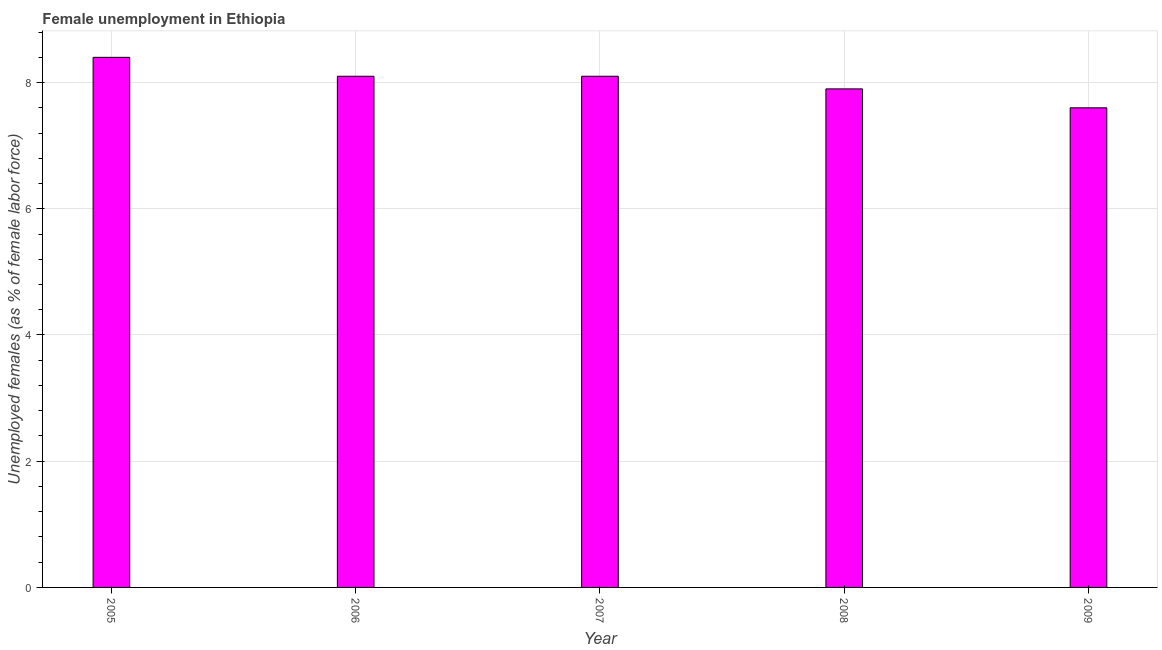Does the graph contain grids?
Offer a very short reply. Yes. What is the title of the graph?
Your answer should be very brief. Female unemployment in Ethiopia. What is the label or title of the X-axis?
Your answer should be compact. Year. What is the label or title of the Y-axis?
Your answer should be compact. Unemployed females (as % of female labor force). What is the unemployed females population in 2008?
Provide a short and direct response. 7.9. Across all years, what is the maximum unemployed females population?
Offer a terse response. 8.4. Across all years, what is the minimum unemployed females population?
Ensure brevity in your answer.  7.6. In which year was the unemployed females population maximum?
Keep it short and to the point. 2005. What is the sum of the unemployed females population?
Your response must be concise. 40.1. What is the difference between the unemployed females population in 2008 and 2009?
Ensure brevity in your answer.  0.3. What is the average unemployed females population per year?
Your answer should be compact. 8.02. What is the median unemployed females population?
Your response must be concise. 8.1. What is the ratio of the unemployed females population in 2006 to that in 2009?
Your answer should be compact. 1.07. Is the unemployed females population in 2006 less than that in 2009?
Make the answer very short. No. How many bars are there?
Give a very brief answer. 5. Are all the bars in the graph horizontal?
Ensure brevity in your answer.  No. How many years are there in the graph?
Ensure brevity in your answer.  5. What is the Unemployed females (as % of female labor force) of 2005?
Provide a succinct answer. 8.4. What is the Unemployed females (as % of female labor force) in 2006?
Your response must be concise. 8.1. What is the Unemployed females (as % of female labor force) of 2007?
Offer a terse response. 8.1. What is the Unemployed females (as % of female labor force) of 2008?
Provide a short and direct response. 7.9. What is the Unemployed females (as % of female labor force) in 2009?
Keep it short and to the point. 7.6. What is the difference between the Unemployed females (as % of female labor force) in 2005 and 2007?
Offer a very short reply. 0.3. What is the difference between the Unemployed females (as % of female labor force) in 2005 and 2009?
Ensure brevity in your answer.  0.8. What is the difference between the Unemployed females (as % of female labor force) in 2006 and 2007?
Ensure brevity in your answer.  0. What is the difference between the Unemployed females (as % of female labor force) in 2006 and 2009?
Provide a succinct answer. 0.5. What is the difference between the Unemployed females (as % of female labor force) in 2007 and 2009?
Provide a short and direct response. 0.5. What is the difference between the Unemployed females (as % of female labor force) in 2008 and 2009?
Your answer should be compact. 0.3. What is the ratio of the Unemployed females (as % of female labor force) in 2005 to that in 2008?
Your answer should be very brief. 1.06. What is the ratio of the Unemployed females (as % of female labor force) in 2005 to that in 2009?
Ensure brevity in your answer.  1.1. What is the ratio of the Unemployed females (as % of female labor force) in 2006 to that in 2007?
Offer a terse response. 1. What is the ratio of the Unemployed females (as % of female labor force) in 2006 to that in 2009?
Provide a short and direct response. 1.07. What is the ratio of the Unemployed females (as % of female labor force) in 2007 to that in 2008?
Keep it short and to the point. 1.02. What is the ratio of the Unemployed females (as % of female labor force) in 2007 to that in 2009?
Your answer should be compact. 1.07. What is the ratio of the Unemployed females (as % of female labor force) in 2008 to that in 2009?
Make the answer very short. 1.04. 